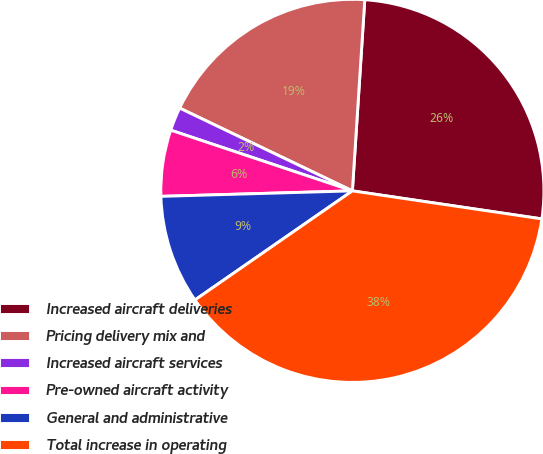Convert chart. <chart><loc_0><loc_0><loc_500><loc_500><pie_chart><fcel>Increased aircraft deliveries<fcel>Pricing delivery mix and<fcel>Increased aircraft services<fcel>Pre-owned aircraft activity<fcel>General and administrative<fcel>Total increase in operating<nl><fcel>26.31%<fcel>18.92%<fcel>1.98%<fcel>5.59%<fcel>9.19%<fcel>38.02%<nl></chart> 